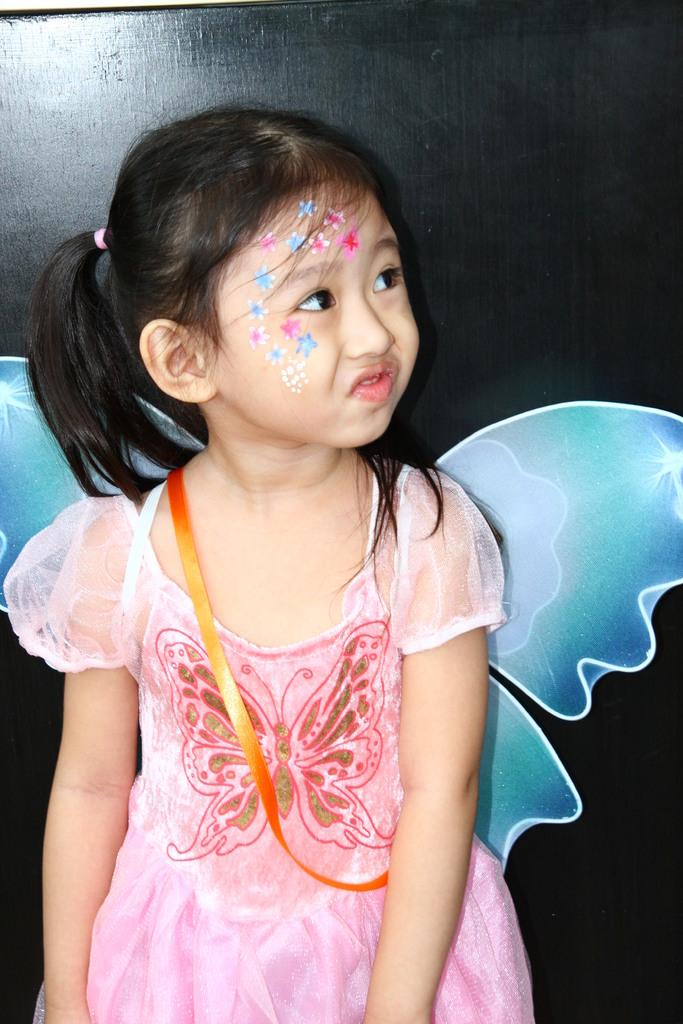Who is the main subject in the image? There is a girl in the image. What is the girl wearing? The girl is wearing a frock with wings attached at the back. What is the girl's posture in the image? The girl is standing. In which direction is the girl looking? The girl is looking to the right. What can be seen in the background of the image? There is a wooden surface in the background. How many legs does the tent have in the image? There is no tent present in the image. What type of stitch is used to attach the wings to the girl's frock? The image does not provide information about the type of stitch used to attach the wings to the girl's frock. 